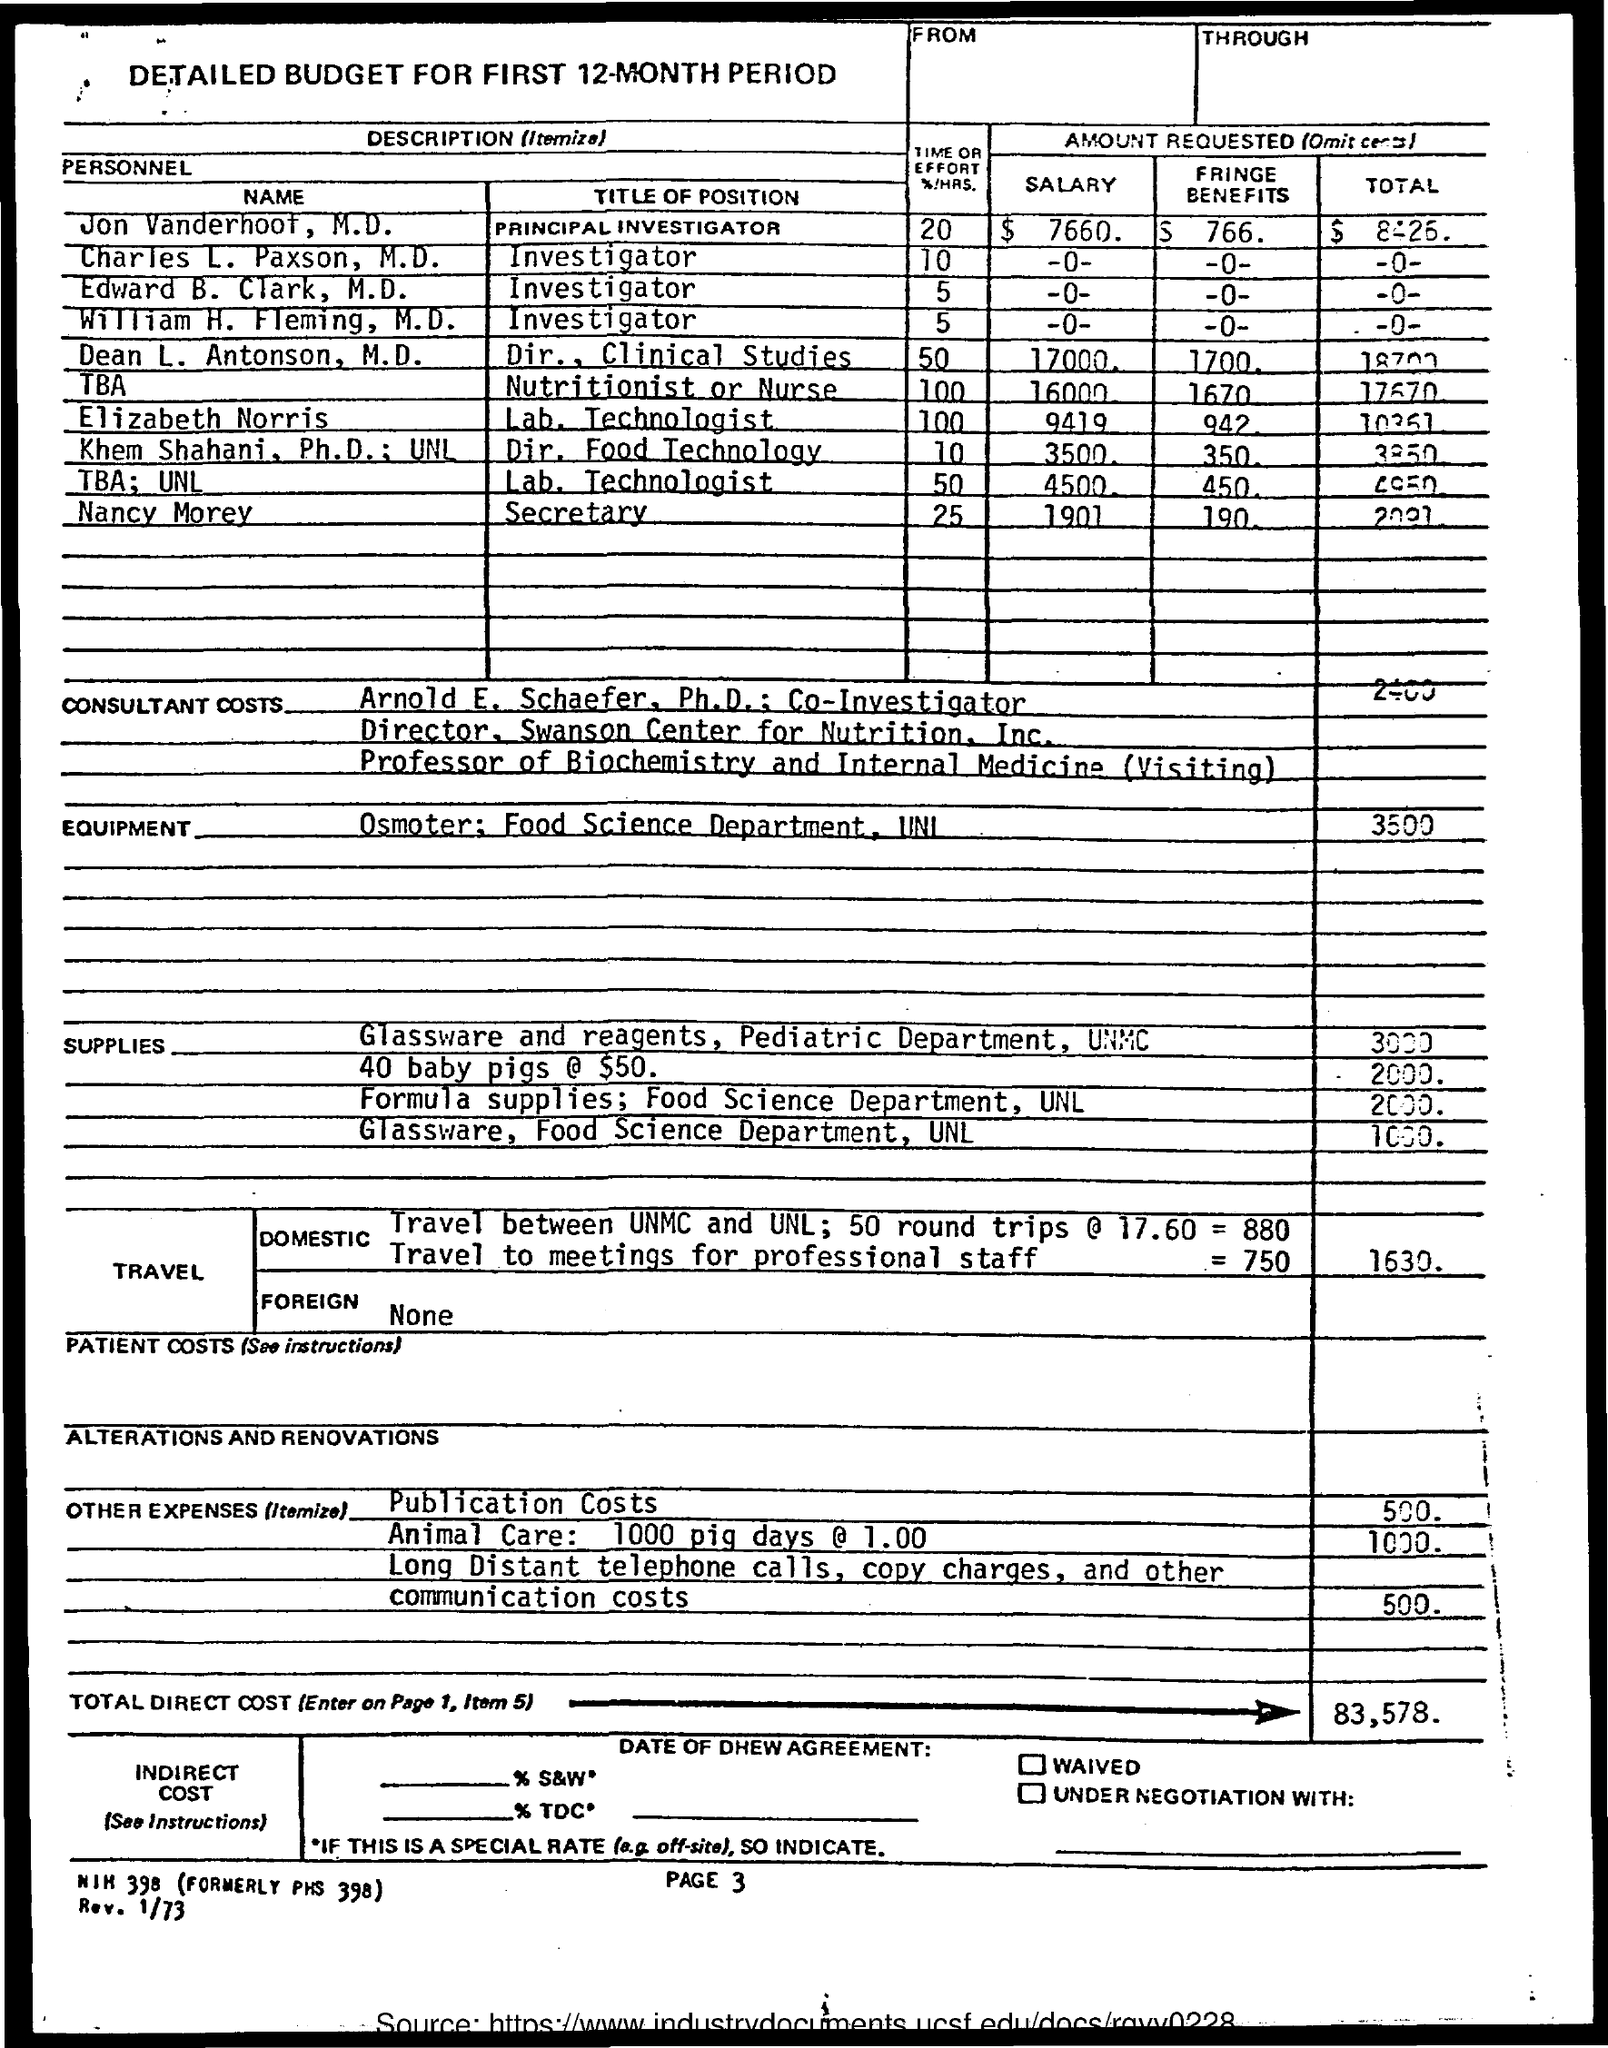Highlight a few significant elements in this photo. Jon Vanderhoof holds the position of Principal Investigator. Elizabeth Norris holds the position of Laboratory Technologist, as stated in the title. The amount mentioned for communication costs is 500.", stated the accountant. Nancy Morey holds the title of Secretary. Charles L. Paxson holds the title of investigator. 